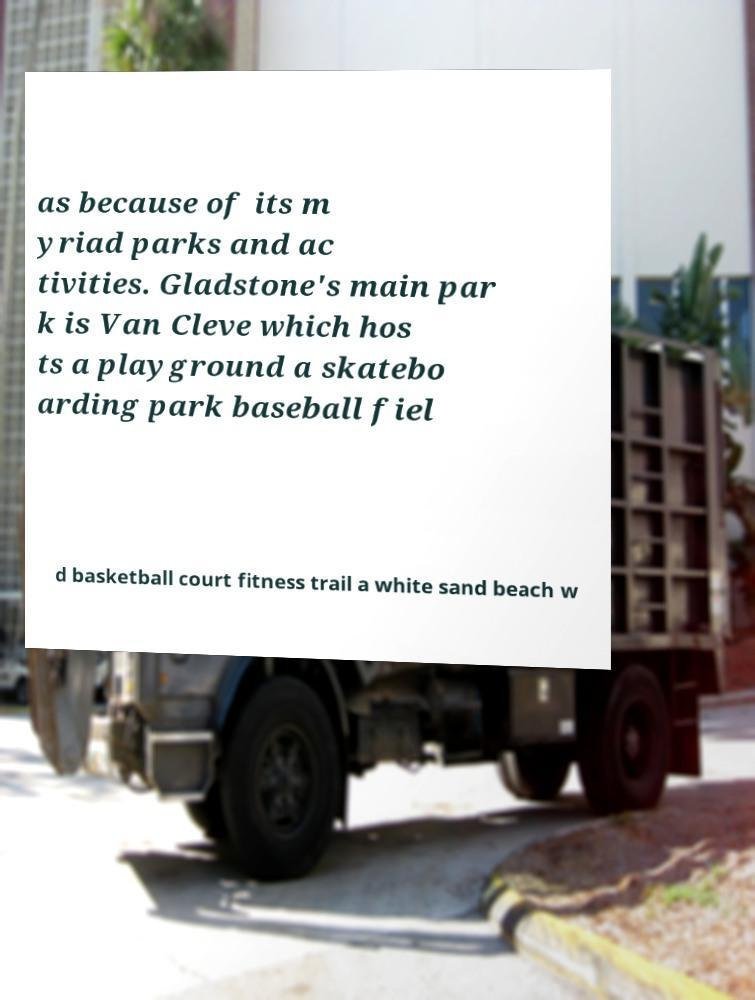I need the written content from this picture converted into text. Can you do that? as because of its m yriad parks and ac tivities. Gladstone's main par k is Van Cleve which hos ts a playground a skatebo arding park baseball fiel d basketball court fitness trail a white sand beach w 